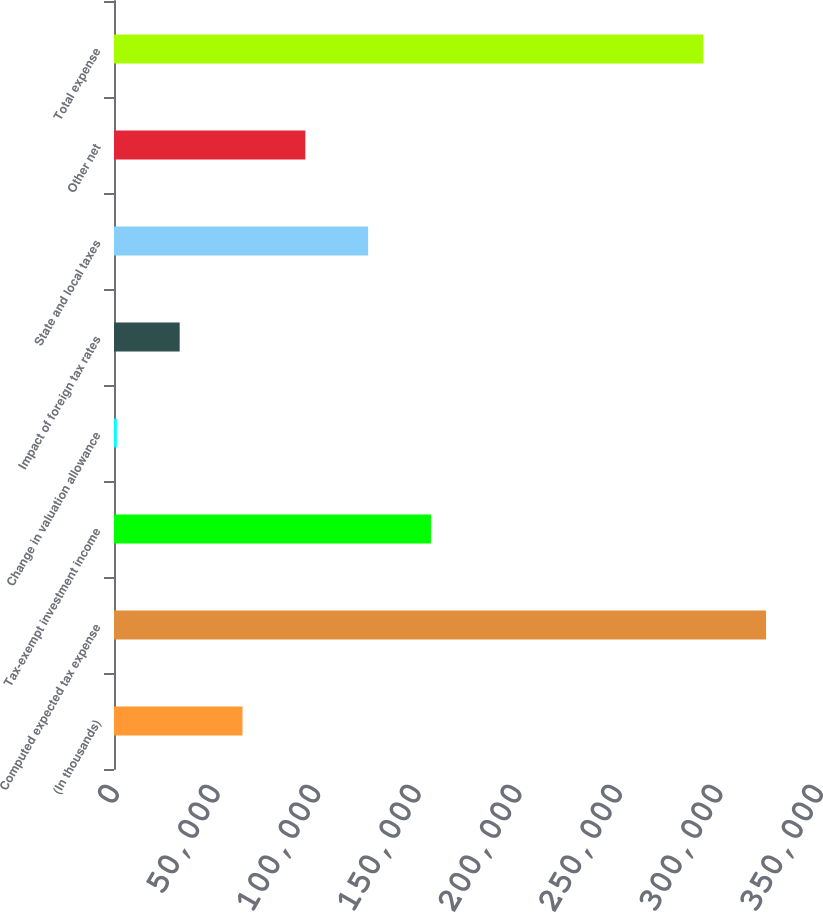<chart> <loc_0><loc_0><loc_500><loc_500><bar_chart><fcel>(In thousands)<fcel>Computed expected tax expense<fcel>Tax-exempt investment income<fcel>Change in valuation allowance<fcel>Impact of foreign tax rates<fcel>State and local taxes<fcel>Other net<fcel>Total expense<nl><fcel>63886.6<fcel>324186<fcel>157586<fcel>1420<fcel>32653.3<fcel>126353<fcel>95119.9<fcel>292953<nl></chart> 